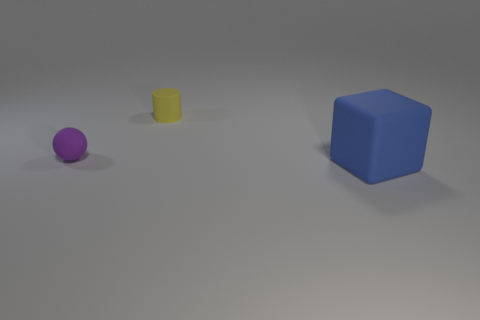There is a matte thing that is behind the ball; does it have the same color as the big rubber thing?
Make the answer very short. No. There is a tiny thing that is on the right side of the purple sphere that is on the left side of the tiny thing to the right of the tiny matte ball; what is it made of?
Ensure brevity in your answer.  Rubber. Are there any other blocks that have the same color as the large cube?
Provide a succinct answer. No. Is the number of matte objects right of the blue object less than the number of large blue matte things?
Offer a very short reply. Yes. Is the size of the rubber thing in front of the rubber sphere the same as the small purple rubber thing?
Provide a short and direct response. No. How many matte objects are in front of the tiny yellow cylinder and to the right of the rubber ball?
Provide a short and direct response. 1. How big is the object behind the small matte thing that is to the left of the small cylinder?
Your response must be concise. Small. Is the number of rubber things to the right of the big matte block less than the number of matte cylinders that are in front of the tiny purple matte sphere?
Your response must be concise. No. There is a tiny matte thing behind the tiny purple object; is it the same color as the rubber object in front of the small purple sphere?
Your answer should be very brief. No. There is a object that is both left of the large blue cube and to the right of the purple thing; what is its material?
Ensure brevity in your answer.  Rubber. 